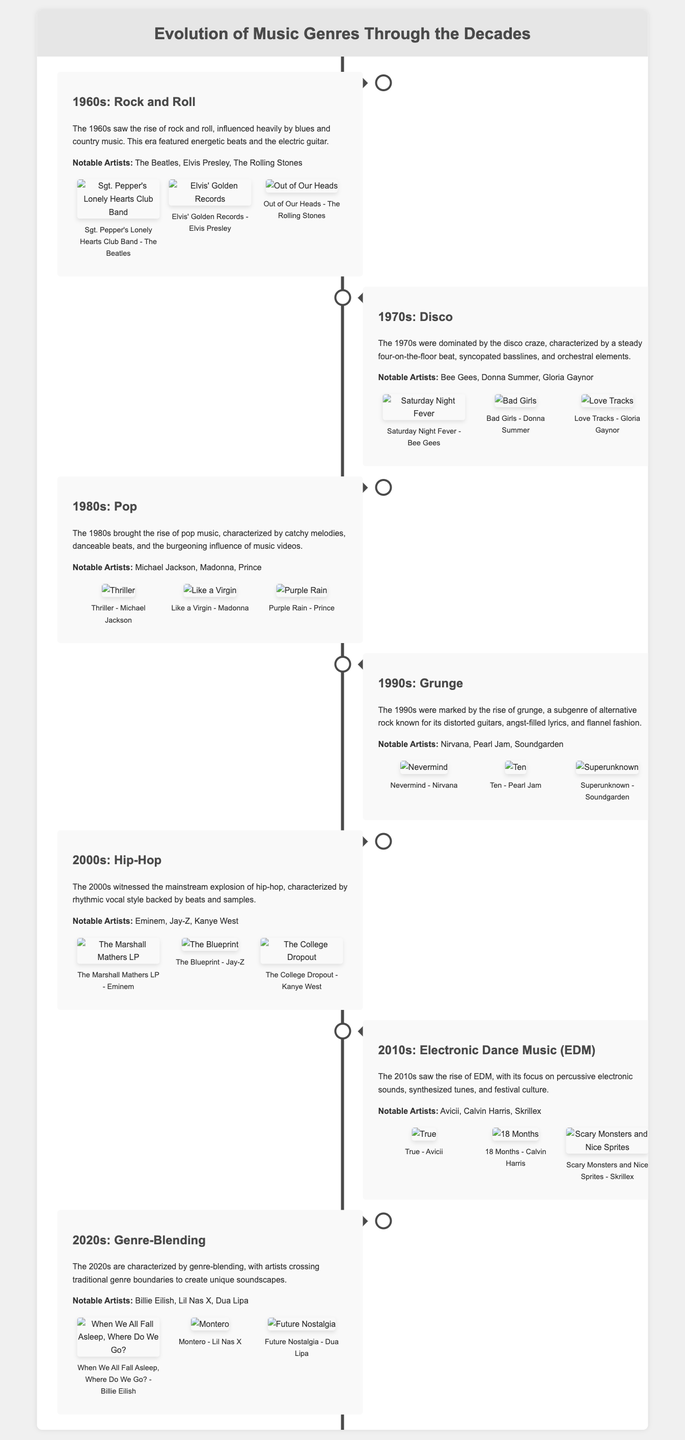What genre dominated the 1970s? The document states that the 1970s were dominated by the disco craze, characterized by its specific musical elements.
Answer: Disco Who was a notable artist of the 1960s? The document lists The Beatles as a prominent artist from the 1960s, indicating their importance during this era.
Answer: The Beatles What is the title of an album from the 1980s? The document mentions "Thriller" by Michael Jackson as a significant album from the 1980s.
Answer: Thriller Which genre emerged prominently in the 1990s? The document specifies that grunge was a defining genre of the 1990s, highlighting its key characteristics.
Answer: Grunge What is a characteristic of the 2020s music scene? The document describes the 2020s as characterized by genre-blending, showcasing innovation in contemporary music.
Answer: Genre-Blending Which artist released an album titled "True"? According to the document, Avicii is credited with the album "True" in the 2010s era of music.
Answer: Avicii What decade is associated with the rise of hip-hop? The document points out that the 2000s saw the explosion of hip-hop in mainstream music culture.
Answer: 2000s How many notable artists from the 2010s are listed? The document lists three artists under the 2010s section, requiring count from the provided data.
Answer: Three What type of music characterized the 1980s? The document outlines that catchy melodies and danceable beats typified the music style of the 1980s.
Answer: Pop 